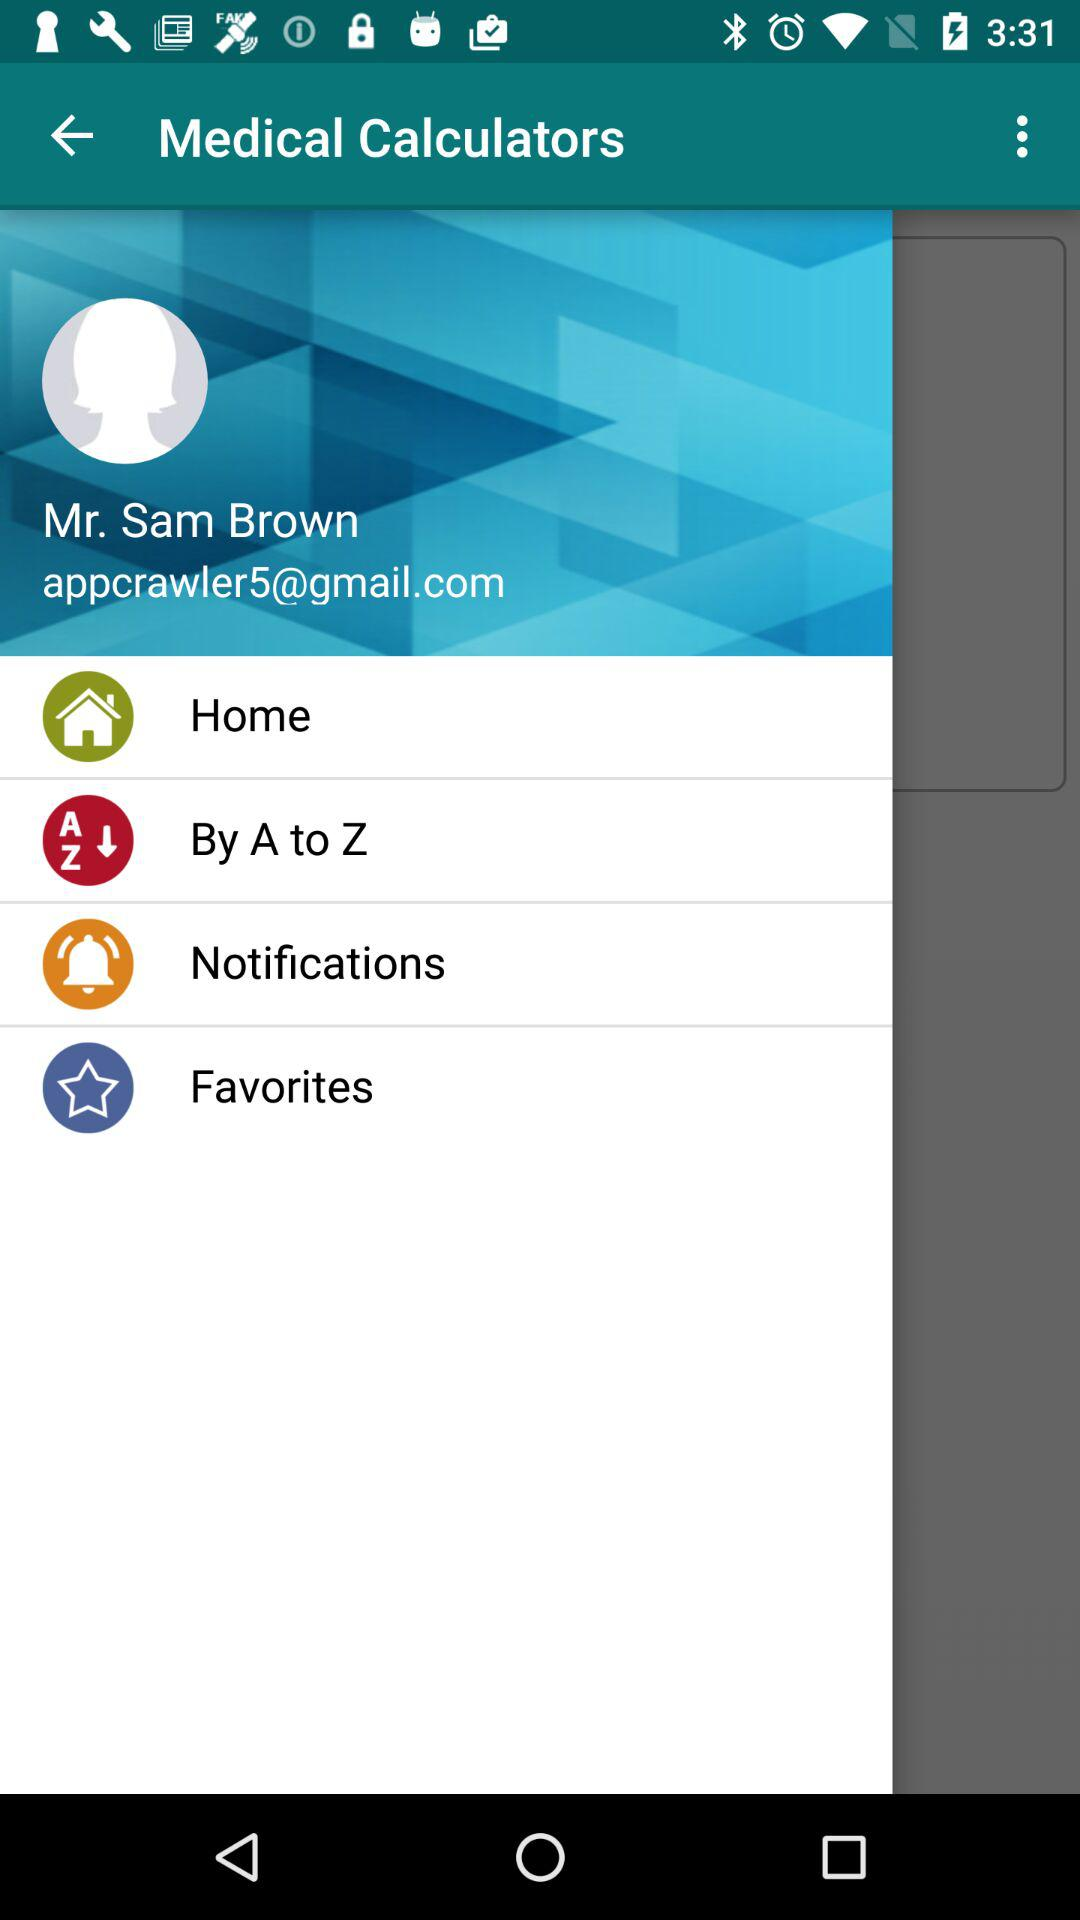What is the app name?
When the provided information is insufficient, respond with <no answer>. <no answer> 